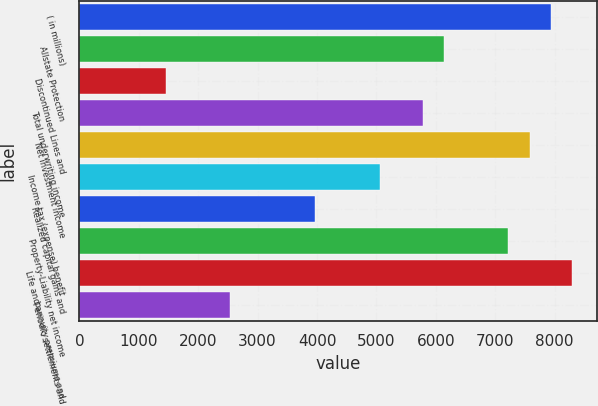Convert chart. <chart><loc_0><loc_0><loc_500><loc_500><bar_chart><fcel>( in millions)<fcel>Allstate Protection<fcel>Discontinued Lines and<fcel>Total underwriting income<fcel>Net investment income<fcel>Income tax (expense) benefit<fcel>Realized capital gains and<fcel>Property-Liability net income<fcel>Life and annuity premiums and<fcel>Periodic settlements and<nl><fcel>7937.8<fcel>6135.8<fcel>1450.6<fcel>5775.4<fcel>7577.4<fcel>5054.6<fcel>3973.4<fcel>7217<fcel>8298.2<fcel>2531.8<nl></chart> 